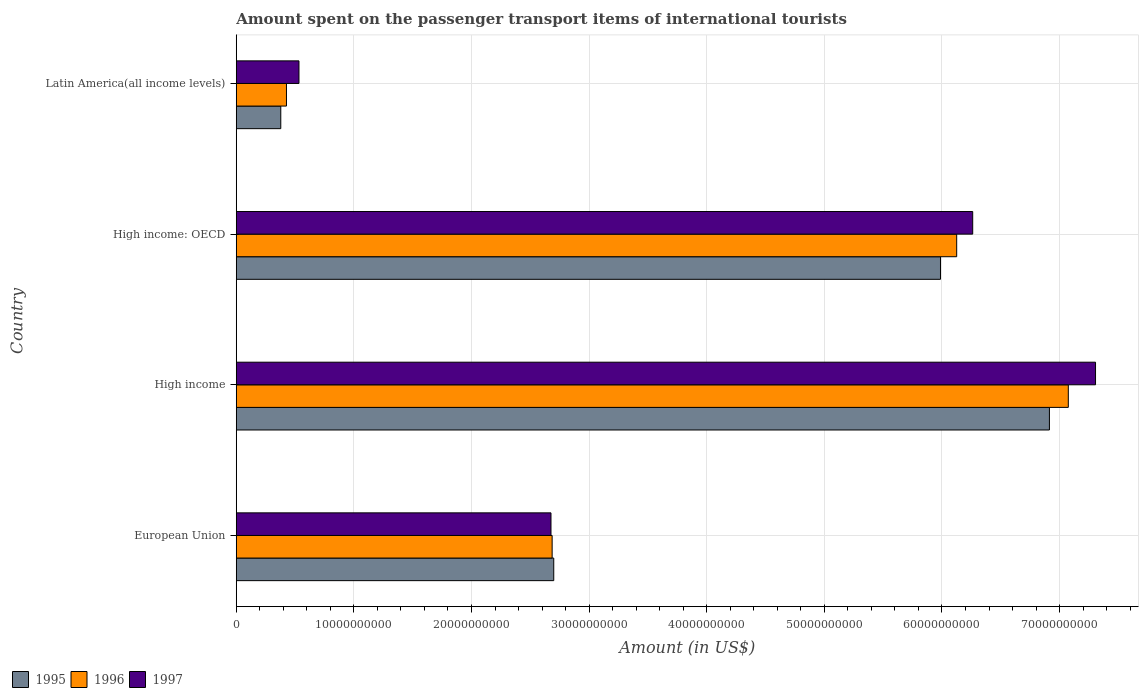How many groups of bars are there?
Make the answer very short. 4. Are the number of bars per tick equal to the number of legend labels?
Give a very brief answer. Yes. Are the number of bars on each tick of the Y-axis equal?
Ensure brevity in your answer.  Yes. How many bars are there on the 4th tick from the bottom?
Make the answer very short. 3. What is the label of the 2nd group of bars from the top?
Keep it short and to the point. High income: OECD. What is the amount spent on the passenger transport items of international tourists in 1996 in High income: OECD?
Provide a succinct answer. 6.12e+1. Across all countries, what is the maximum amount spent on the passenger transport items of international tourists in 1997?
Your response must be concise. 7.31e+1. Across all countries, what is the minimum amount spent on the passenger transport items of international tourists in 1995?
Offer a very short reply. 3.79e+09. In which country was the amount spent on the passenger transport items of international tourists in 1995 maximum?
Offer a terse response. High income. In which country was the amount spent on the passenger transport items of international tourists in 1996 minimum?
Your answer should be very brief. Latin America(all income levels). What is the total amount spent on the passenger transport items of international tourists in 1997 in the graph?
Your answer should be very brief. 1.68e+11. What is the difference between the amount spent on the passenger transport items of international tourists in 1997 in High income and that in Latin America(all income levels)?
Make the answer very short. 6.77e+1. What is the difference between the amount spent on the passenger transport items of international tourists in 1996 in European Union and the amount spent on the passenger transport items of international tourists in 1997 in Latin America(all income levels)?
Ensure brevity in your answer.  2.15e+1. What is the average amount spent on the passenger transport items of international tourists in 1995 per country?
Provide a succinct answer. 3.99e+1. What is the difference between the amount spent on the passenger transport items of international tourists in 1997 and amount spent on the passenger transport items of international tourists in 1995 in High income?
Provide a succinct answer. 3.92e+09. In how many countries, is the amount spent on the passenger transport items of international tourists in 1996 greater than 56000000000 US$?
Your answer should be compact. 2. What is the ratio of the amount spent on the passenger transport items of international tourists in 1997 in High income to that in Latin America(all income levels)?
Your response must be concise. 13.7. Is the difference between the amount spent on the passenger transport items of international tourists in 1997 in European Union and High income greater than the difference between the amount spent on the passenger transport items of international tourists in 1995 in European Union and High income?
Ensure brevity in your answer.  No. What is the difference between the highest and the second highest amount spent on the passenger transport items of international tourists in 1995?
Keep it short and to the point. 9.26e+09. What is the difference between the highest and the lowest amount spent on the passenger transport items of international tourists in 1995?
Provide a short and direct response. 6.53e+1. In how many countries, is the amount spent on the passenger transport items of international tourists in 1997 greater than the average amount spent on the passenger transport items of international tourists in 1997 taken over all countries?
Your response must be concise. 2. What does the 3rd bar from the top in Latin America(all income levels) represents?
Keep it short and to the point. 1995. What does the 2nd bar from the bottom in Latin America(all income levels) represents?
Your answer should be very brief. 1996. How many bars are there?
Offer a very short reply. 12. What is the difference between two consecutive major ticks on the X-axis?
Offer a terse response. 1.00e+1. How many legend labels are there?
Your answer should be compact. 3. What is the title of the graph?
Offer a terse response. Amount spent on the passenger transport items of international tourists. What is the Amount (in US$) in 1995 in European Union?
Your answer should be compact. 2.70e+1. What is the Amount (in US$) of 1996 in European Union?
Ensure brevity in your answer.  2.69e+1. What is the Amount (in US$) in 1997 in European Union?
Ensure brevity in your answer.  2.68e+1. What is the Amount (in US$) of 1995 in High income?
Your answer should be compact. 6.91e+1. What is the Amount (in US$) of 1996 in High income?
Make the answer very short. 7.07e+1. What is the Amount (in US$) of 1997 in High income?
Ensure brevity in your answer.  7.31e+1. What is the Amount (in US$) in 1995 in High income: OECD?
Provide a short and direct response. 5.99e+1. What is the Amount (in US$) in 1996 in High income: OECD?
Keep it short and to the point. 6.12e+1. What is the Amount (in US$) in 1997 in High income: OECD?
Your answer should be very brief. 6.26e+1. What is the Amount (in US$) of 1995 in Latin America(all income levels)?
Your answer should be very brief. 3.79e+09. What is the Amount (in US$) of 1996 in Latin America(all income levels)?
Your answer should be compact. 4.27e+09. What is the Amount (in US$) of 1997 in Latin America(all income levels)?
Your response must be concise. 5.33e+09. Across all countries, what is the maximum Amount (in US$) of 1995?
Ensure brevity in your answer.  6.91e+1. Across all countries, what is the maximum Amount (in US$) in 1996?
Give a very brief answer. 7.07e+1. Across all countries, what is the maximum Amount (in US$) in 1997?
Offer a very short reply. 7.31e+1. Across all countries, what is the minimum Amount (in US$) in 1995?
Give a very brief answer. 3.79e+09. Across all countries, what is the minimum Amount (in US$) of 1996?
Offer a terse response. 4.27e+09. Across all countries, what is the minimum Amount (in US$) in 1997?
Keep it short and to the point. 5.33e+09. What is the total Amount (in US$) in 1995 in the graph?
Keep it short and to the point. 1.60e+11. What is the total Amount (in US$) in 1996 in the graph?
Provide a short and direct response. 1.63e+11. What is the total Amount (in US$) of 1997 in the graph?
Give a very brief answer. 1.68e+11. What is the difference between the Amount (in US$) in 1995 in European Union and that in High income?
Ensure brevity in your answer.  -4.21e+1. What is the difference between the Amount (in US$) of 1996 in European Union and that in High income?
Provide a succinct answer. -4.39e+1. What is the difference between the Amount (in US$) of 1997 in European Union and that in High income?
Provide a short and direct response. -4.63e+1. What is the difference between the Amount (in US$) of 1995 in European Union and that in High income: OECD?
Your answer should be compact. -3.29e+1. What is the difference between the Amount (in US$) in 1996 in European Union and that in High income: OECD?
Keep it short and to the point. -3.44e+1. What is the difference between the Amount (in US$) of 1997 in European Union and that in High income: OECD?
Ensure brevity in your answer.  -3.59e+1. What is the difference between the Amount (in US$) of 1995 in European Union and that in Latin America(all income levels)?
Provide a short and direct response. 2.32e+1. What is the difference between the Amount (in US$) in 1996 in European Union and that in Latin America(all income levels)?
Your response must be concise. 2.26e+1. What is the difference between the Amount (in US$) of 1997 in European Union and that in Latin America(all income levels)?
Offer a terse response. 2.14e+1. What is the difference between the Amount (in US$) of 1995 in High income and that in High income: OECD?
Ensure brevity in your answer.  9.26e+09. What is the difference between the Amount (in US$) of 1996 in High income and that in High income: OECD?
Your answer should be very brief. 9.49e+09. What is the difference between the Amount (in US$) in 1997 in High income and that in High income: OECD?
Your response must be concise. 1.04e+1. What is the difference between the Amount (in US$) of 1995 in High income and that in Latin America(all income levels)?
Give a very brief answer. 6.53e+1. What is the difference between the Amount (in US$) of 1996 in High income and that in Latin America(all income levels)?
Offer a very short reply. 6.65e+1. What is the difference between the Amount (in US$) in 1997 in High income and that in Latin America(all income levels)?
Give a very brief answer. 6.77e+1. What is the difference between the Amount (in US$) in 1995 in High income: OECD and that in Latin America(all income levels)?
Provide a short and direct response. 5.61e+1. What is the difference between the Amount (in US$) of 1996 in High income: OECD and that in Latin America(all income levels)?
Offer a very short reply. 5.70e+1. What is the difference between the Amount (in US$) in 1997 in High income: OECD and that in Latin America(all income levels)?
Make the answer very short. 5.73e+1. What is the difference between the Amount (in US$) of 1995 in European Union and the Amount (in US$) of 1996 in High income?
Provide a succinct answer. -4.37e+1. What is the difference between the Amount (in US$) in 1995 in European Union and the Amount (in US$) in 1997 in High income?
Provide a short and direct response. -4.61e+1. What is the difference between the Amount (in US$) in 1996 in European Union and the Amount (in US$) in 1997 in High income?
Your answer should be compact. -4.62e+1. What is the difference between the Amount (in US$) in 1995 in European Union and the Amount (in US$) in 1996 in High income: OECD?
Provide a short and direct response. -3.43e+1. What is the difference between the Amount (in US$) of 1995 in European Union and the Amount (in US$) of 1997 in High income: OECD?
Your response must be concise. -3.56e+1. What is the difference between the Amount (in US$) in 1996 in European Union and the Amount (in US$) in 1997 in High income: OECD?
Give a very brief answer. -3.58e+1. What is the difference between the Amount (in US$) of 1995 in European Union and the Amount (in US$) of 1996 in Latin America(all income levels)?
Your answer should be compact. 2.27e+1. What is the difference between the Amount (in US$) of 1995 in European Union and the Amount (in US$) of 1997 in Latin America(all income levels)?
Ensure brevity in your answer.  2.17e+1. What is the difference between the Amount (in US$) in 1996 in European Union and the Amount (in US$) in 1997 in Latin America(all income levels)?
Your response must be concise. 2.15e+1. What is the difference between the Amount (in US$) of 1995 in High income and the Amount (in US$) of 1996 in High income: OECD?
Your answer should be compact. 7.88e+09. What is the difference between the Amount (in US$) in 1995 in High income and the Amount (in US$) in 1997 in High income: OECD?
Provide a succinct answer. 6.52e+09. What is the difference between the Amount (in US$) of 1996 in High income and the Amount (in US$) of 1997 in High income: OECD?
Your answer should be very brief. 8.13e+09. What is the difference between the Amount (in US$) of 1995 in High income and the Amount (in US$) of 1996 in Latin America(all income levels)?
Ensure brevity in your answer.  6.49e+1. What is the difference between the Amount (in US$) of 1995 in High income and the Amount (in US$) of 1997 in Latin America(all income levels)?
Ensure brevity in your answer.  6.38e+1. What is the difference between the Amount (in US$) in 1996 in High income and the Amount (in US$) in 1997 in Latin America(all income levels)?
Provide a short and direct response. 6.54e+1. What is the difference between the Amount (in US$) in 1995 in High income: OECD and the Amount (in US$) in 1996 in Latin America(all income levels)?
Your response must be concise. 5.56e+1. What is the difference between the Amount (in US$) in 1995 in High income: OECD and the Amount (in US$) in 1997 in Latin America(all income levels)?
Offer a very short reply. 5.45e+1. What is the difference between the Amount (in US$) of 1996 in High income: OECD and the Amount (in US$) of 1997 in Latin America(all income levels)?
Make the answer very short. 5.59e+1. What is the average Amount (in US$) in 1995 per country?
Ensure brevity in your answer.  3.99e+1. What is the average Amount (in US$) of 1996 per country?
Provide a short and direct response. 4.08e+1. What is the average Amount (in US$) in 1997 per country?
Provide a succinct answer. 4.19e+1. What is the difference between the Amount (in US$) of 1995 and Amount (in US$) of 1996 in European Union?
Your answer should be compact. 1.37e+08. What is the difference between the Amount (in US$) of 1995 and Amount (in US$) of 1997 in European Union?
Offer a terse response. 2.35e+08. What is the difference between the Amount (in US$) of 1996 and Amount (in US$) of 1997 in European Union?
Make the answer very short. 9.81e+07. What is the difference between the Amount (in US$) in 1995 and Amount (in US$) in 1996 in High income?
Your answer should be very brief. -1.61e+09. What is the difference between the Amount (in US$) of 1995 and Amount (in US$) of 1997 in High income?
Offer a terse response. -3.92e+09. What is the difference between the Amount (in US$) in 1996 and Amount (in US$) in 1997 in High income?
Offer a very short reply. -2.31e+09. What is the difference between the Amount (in US$) of 1995 and Amount (in US$) of 1996 in High income: OECD?
Your answer should be very brief. -1.38e+09. What is the difference between the Amount (in US$) of 1995 and Amount (in US$) of 1997 in High income: OECD?
Keep it short and to the point. -2.74e+09. What is the difference between the Amount (in US$) of 1996 and Amount (in US$) of 1997 in High income: OECD?
Keep it short and to the point. -1.36e+09. What is the difference between the Amount (in US$) in 1995 and Amount (in US$) in 1996 in Latin America(all income levels)?
Provide a short and direct response. -4.84e+08. What is the difference between the Amount (in US$) in 1995 and Amount (in US$) in 1997 in Latin America(all income levels)?
Ensure brevity in your answer.  -1.55e+09. What is the difference between the Amount (in US$) in 1996 and Amount (in US$) in 1997 in Latin America(all income levels)?
Make the answer very short. -1.06e+09. What is the ratio of the Amount (in US$) of 1995 in European Union to that in High income?
Keep it short and to the point. 0.39. What is the ratio of the Amount (in US$) of 1996 in European Union to that in High income?
Provide a short and direct response. 0.38. What is the ratio of the Amount (in US$) of 1997 in European Union to that in High income?
Provide a short and direct response. 0.37. What is the ratio of the Amount (in US$) of 1995 in European Union to that in High income: OECD?
Your answer should be compact. 0.45. What is the ratio of the Amount (in US$) in 1996 in European Union to that in High income: OECD?
Your answer should be very brief. 0.44. What is the ratio of the Amount (in US$) in 1997 in European Union to that in High income: OECD?
Provide a short and direct response. 0.43. What is the ratio of the Amount (in US$) of 1995 in European Union to that in Latin America(all income levels)?
Offer a very short reply. 7.13. What is the ratio of the Amount (in US$) in 1996 in European Union to that in Latin America(all income levels)?
Offer a very short reply. 6.29. What is the ratio of the Amount (in US$) in 1997 in European Union to that in Latin America(all income levels)?
Offer a very short reply. 5.02. What is the ratio of the Amount (in US$) in 1995 in High income to that in High income: OECD?
Your answer should be compact. 1.15. What is the ratio of the Amount (in US$) of 1996 in High income to that in High income: OECD?
Your answer should be compact. 1.15. What is the ratio of the Amount (in US$) of 1997 in High income to that in High income: OECD?
Provide a short and direct response. 1.17. What is the ratio of the Amount (in US$) in 1995 in High income to that in Latin America(all income levels)?
Your response must be concise. 18.26. What is the ratio of the Amount (in US$) in 1996 in High income to that in Latin America(all income levels)?
Offer a very short reply. 16.57. What is the ratio of the Amount (in US$) in 1997 in High income to that in Latin America(all income levels)?
Offer a terse response. 13.7. What is the ratio of the Amount (in US$) in 1995 in High income: OECD to that in Latin America(all income levels)?
Your answer should be compact. 15.82. What is the ratio of the Amount (in US$) of 1996 in High income: OECD to that in Latin America(all income levels)?
Offer a terse response. 14.35. What is the ratio of the Amount (in US$) in 1997 in High income: OECD to that in Latin America(all income levels)?
Your answer should be compact. 11.74. What is the difference between the highest and the second highest Amount (in US$) in 1995?
Your response must be concise. 9.26e+09. What is the difference between the highest and the second highest Amount (in US$) in 1996?
Offer a very short reply. 9.49e+09. What is the difference between the highest and the second highest Amount (in US$) of 1997?
Your response must be concise. 1.04e+1. What is the difference between the highest and the lowest Amount (in US$) of 1995?
Give a very brief answer. 6.53e+1. What is the difference between the highest and the lowest Amount (in US$) in 1996?
Ensure brevity in your answer.  6.65e+1. What is the difference between the highest and the lowest Amount (in US$) of 1997?
Keep it short and to the point. 6.77e+1. 